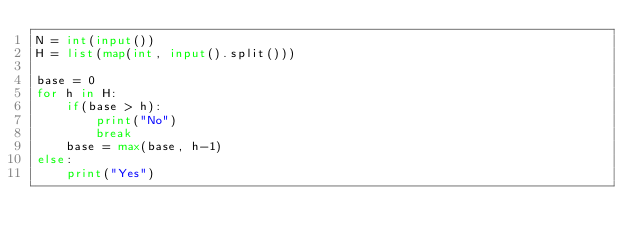<code> <loc_0><loc_0><loc_500><loc_500><_Python_>N = int(input())
H = list(map(int, input().split()))

base = 0
for h in H:
    if(base > h):
        print("No")
        break
    base = max(base, h-1)
else:
    print("Yes")
</code> 